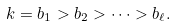<formula> <loc_0><loc_0><loc_500><loc_500>k = b _ { 1 } > b _ { 2 } > \cdots > b _ { \ell } .</formula> 